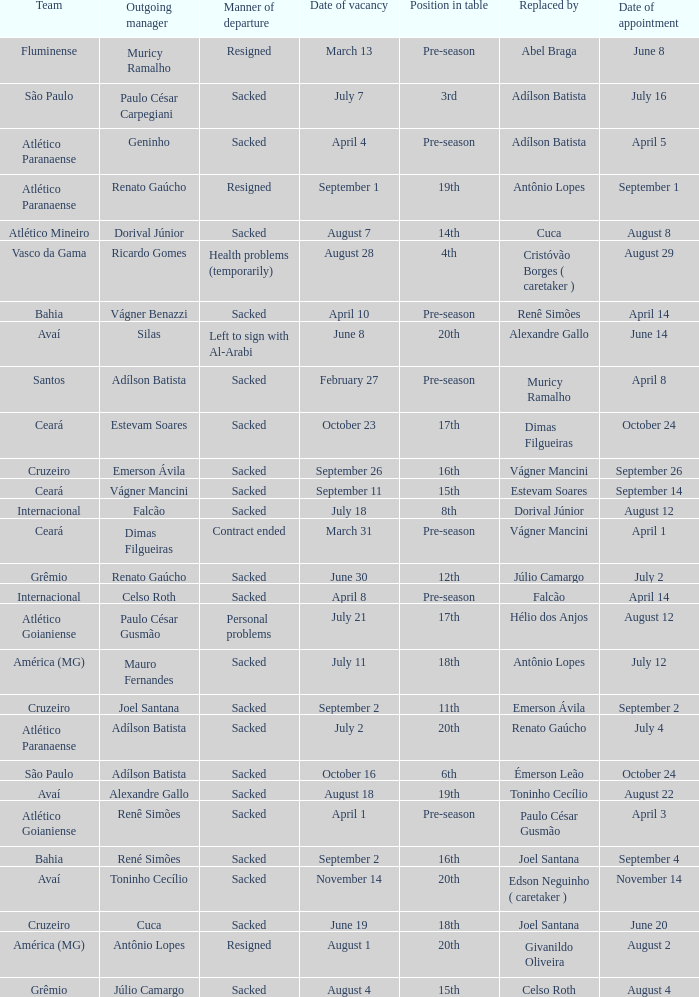Who was replaced as manager on June 20? Cuca. 